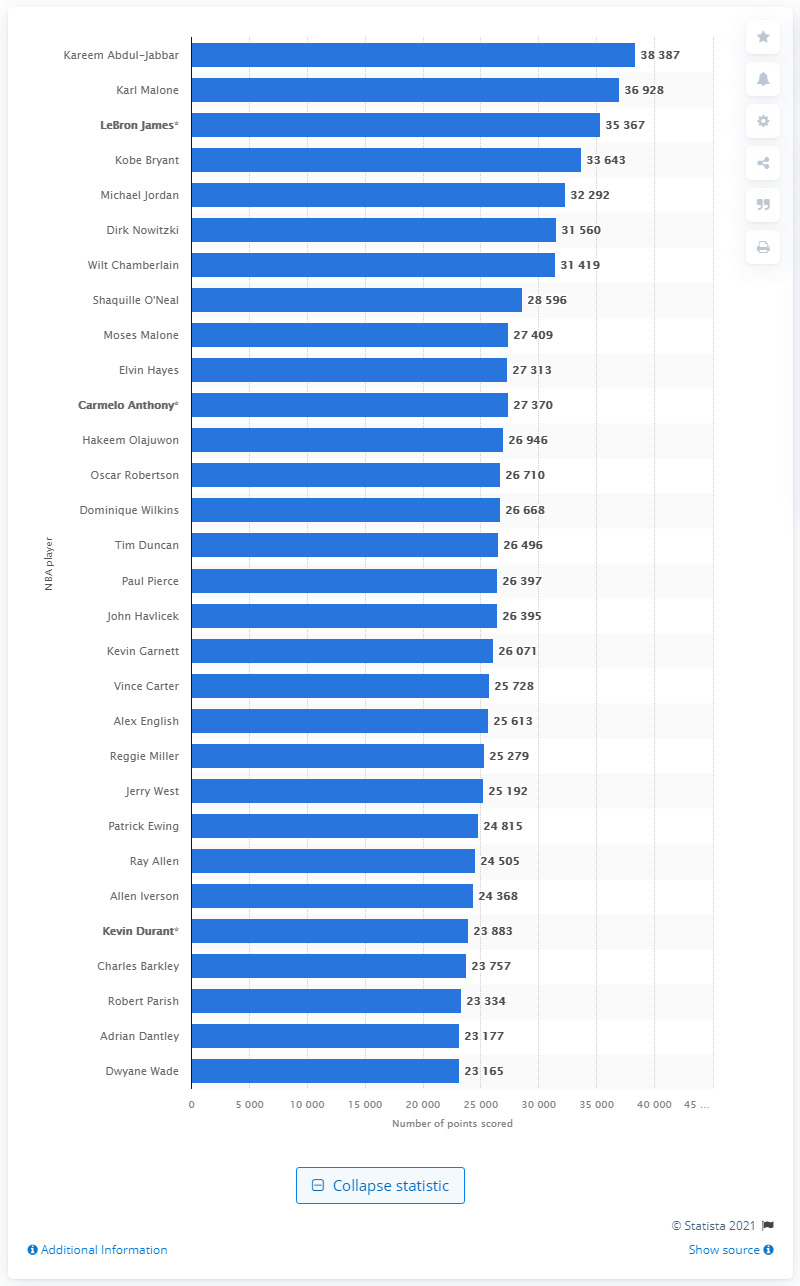Who is the NBA's current all-time leading scorer? As of now, Kareem Abdul-Jabbar holds the prestigious title of the NBA's all-time leading scorer, boasting an impressive total of 38,387 points scored throughout his illustrious career. 